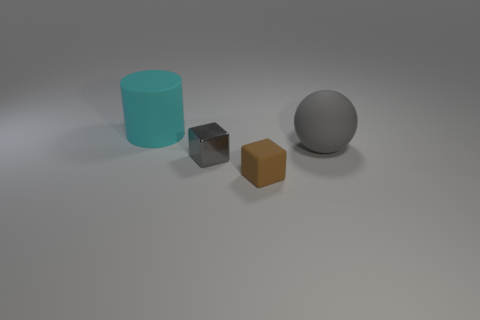Are there any other things that have the same shape as the big cyan rubber thing?
Keep it short and to the point. No. There is a large matte thing that is in front of the big rubber object to the left of the small gray shiny block; are there any big cyan cylinders that are behind it?
Offer a very short reply. Yes. Are the large object that is in front of the cyan matte thing and the gray object that is in front of the big gray ball made of the same material?
Your answer should be very brief. No. What number of objects are big gray spheres or gray matte things that are on the right side of the brown matte object?
Your response must be concise. 1. How many tiny brown things are the same shape as the gray metallic thing?
Offer a terse response. 1. What is the material of the thing that is the same size as the brown block?
Offer a terse response. Metal. There is a rubber thing that is in front of the gray thing in front of the large rubber thing to the right of the cyan thing; what is its size?
Ensure brevity in your answer.  Small. Do the large matte object that is in front of the cyan rubber cylinder and the small thing that is behind the small brown rubber object have the same color?
Your answer should be very brief. Yes. What number of brown things are small cylinders or tiny metallic things?
Offer a terse response. 0. How many cyan cylinders are the same size as the metal object?
Offer a very short reply. 0. 